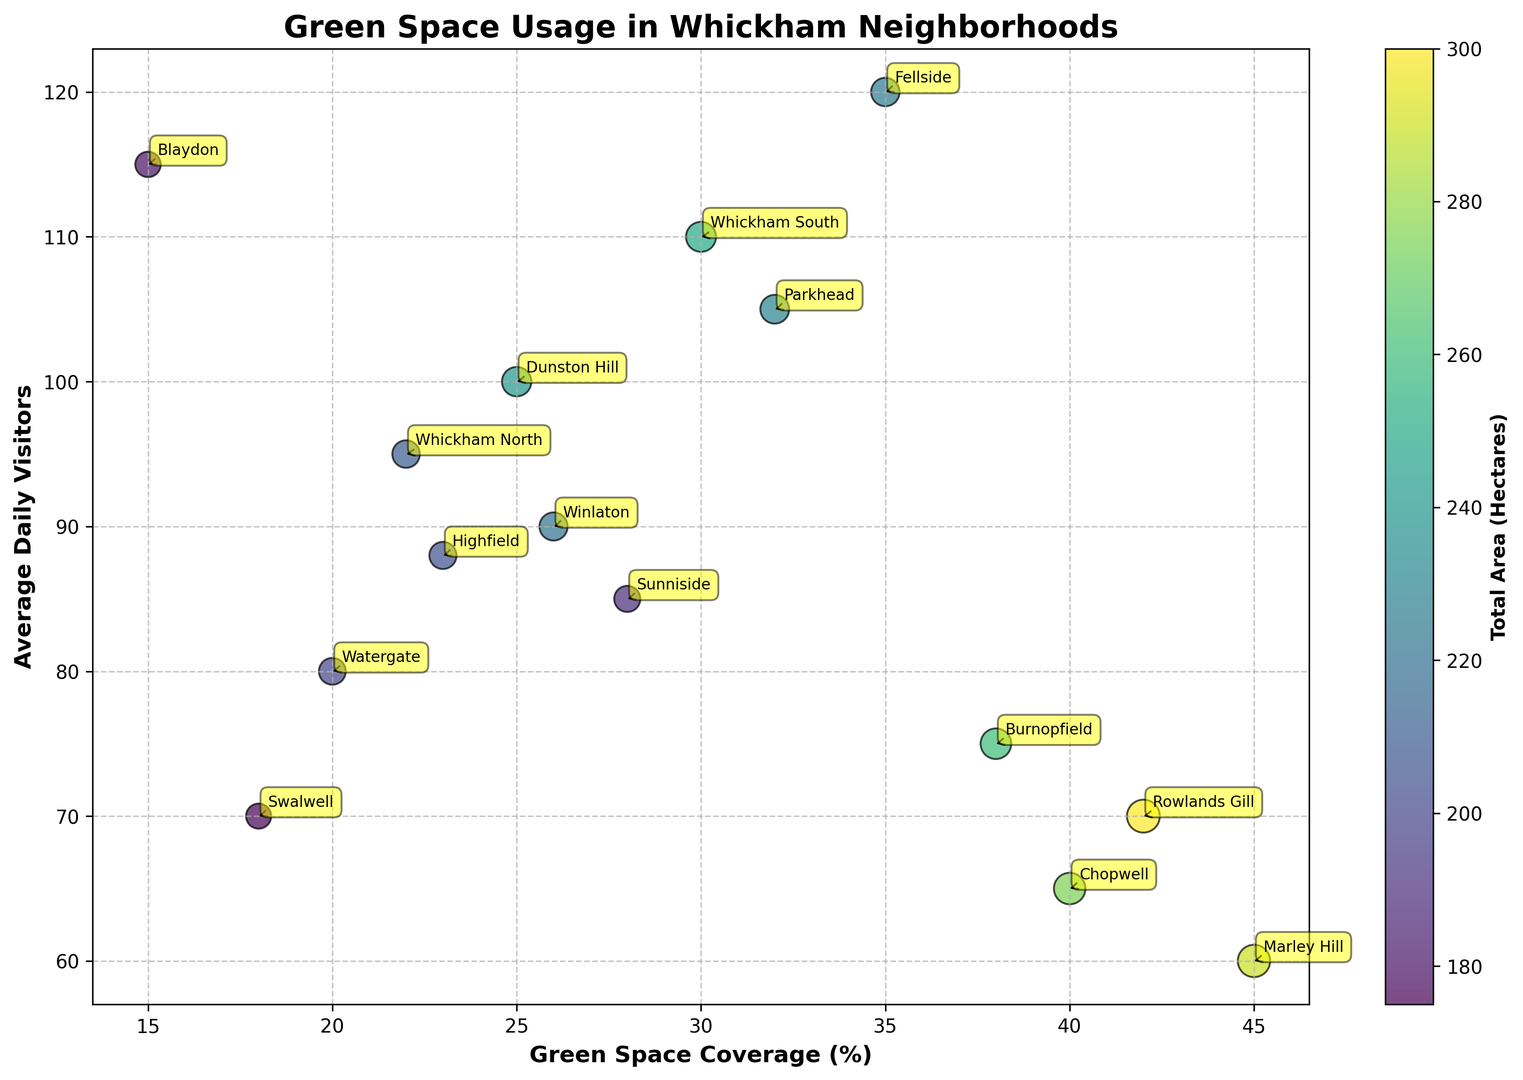How many neighborhoods have more than 30 percent green space coverage? By looking at the x-axis (Green Space Coverage %) and counting the bubbles that have an x-value greater than 30, we find the neighborhoods Fellside, Whitkham South, Chopwell, Parkhead, Burnopfield, Marley Hill, and Rowlands Gill.
Answer: 7 Which neighborhood has the highest average daily visitors and what is its green space coverage percent? By looking at the y-axis (Average Daily Visitors) to find the highest value, we see that Blaydon has the highest average daily visitors at 115. Its corresponding green space coverage percent on the x-axis is 15%.
Answer: Blaydon, 15% Among the neighborhoods with green space coverage greater than 35%, which one has the smallest total area (hectares)? We look for neighborhoods with green space coverage greater than 35% (Fellside, Chopwell, Burnopfield, Marley Hill, Rowlands Gill) and compare their bubble sizes. Fellside has the smallest bubble size, indicating the smallest total area of 45 hectares.
Answer: Fellside Which neighborhood with a green space coverage of at least 30% has the lowest average daily visitors? By checking neighborhoods with a green space coverage of at least 30% (Fellside, Whickham South, Parkhead, Burnopfield, Marley Hill, Rowlands Gill) and comparing their average daily visitors (y-axis), we find that Marley Hill has the lowest average daily visitors at 60.
Answer: Marley Hill Compare the green space coverage between Highfield and Watergate. Which one has a higher percentage and by how much? Highfield has a green space coverage of 23%, and Watergate has a green space coverage of 20%. Subtracting these values gives the difference. 23% - 20% = 3%. Therefore, Highfield has a higher green space coverage by 3%.
Answer: Highfield, by 3% What is the color range of the bubbles and what attribute does it represent? The color range of the bubbles varies from dark to light shades. This gradient represents the total area in hectares, with darker shades indicating larger areas and lighter shades indicating smaller areas.
Answer: Gradient, total area How many neighborhoods have more than 90 average daily visitors? By counting the bubbles with y-values greater than 90 (Average Daily Visitors), the neighborhoods are Fellside, Whickham North, Whickham South, Dunston Hill, Blaydon, and Parkhead.
Answer: 6 Compare the total area of Whickham North and Marley Hill. Which one has a larger area and by how much? Whickham North has a total area of 42 hectares, and Marley Hill has a total area of 58 hectares. Subtracting these values gives the difference. 58 - 42 = 16 hectares. Therefore, Marley Hill has a larger total area by 16 hectares.
Answer: Marley Hill, by 16 hectares Which neighborhood has the smallest green space coverage and how many average daily visitors does it have? The smallest green space coverage is indicated by the lowest x-value. Swalwell has the smallest green space coverage at 18%. It has 70 average daily visitors.
Answer: Swalwell, 70 